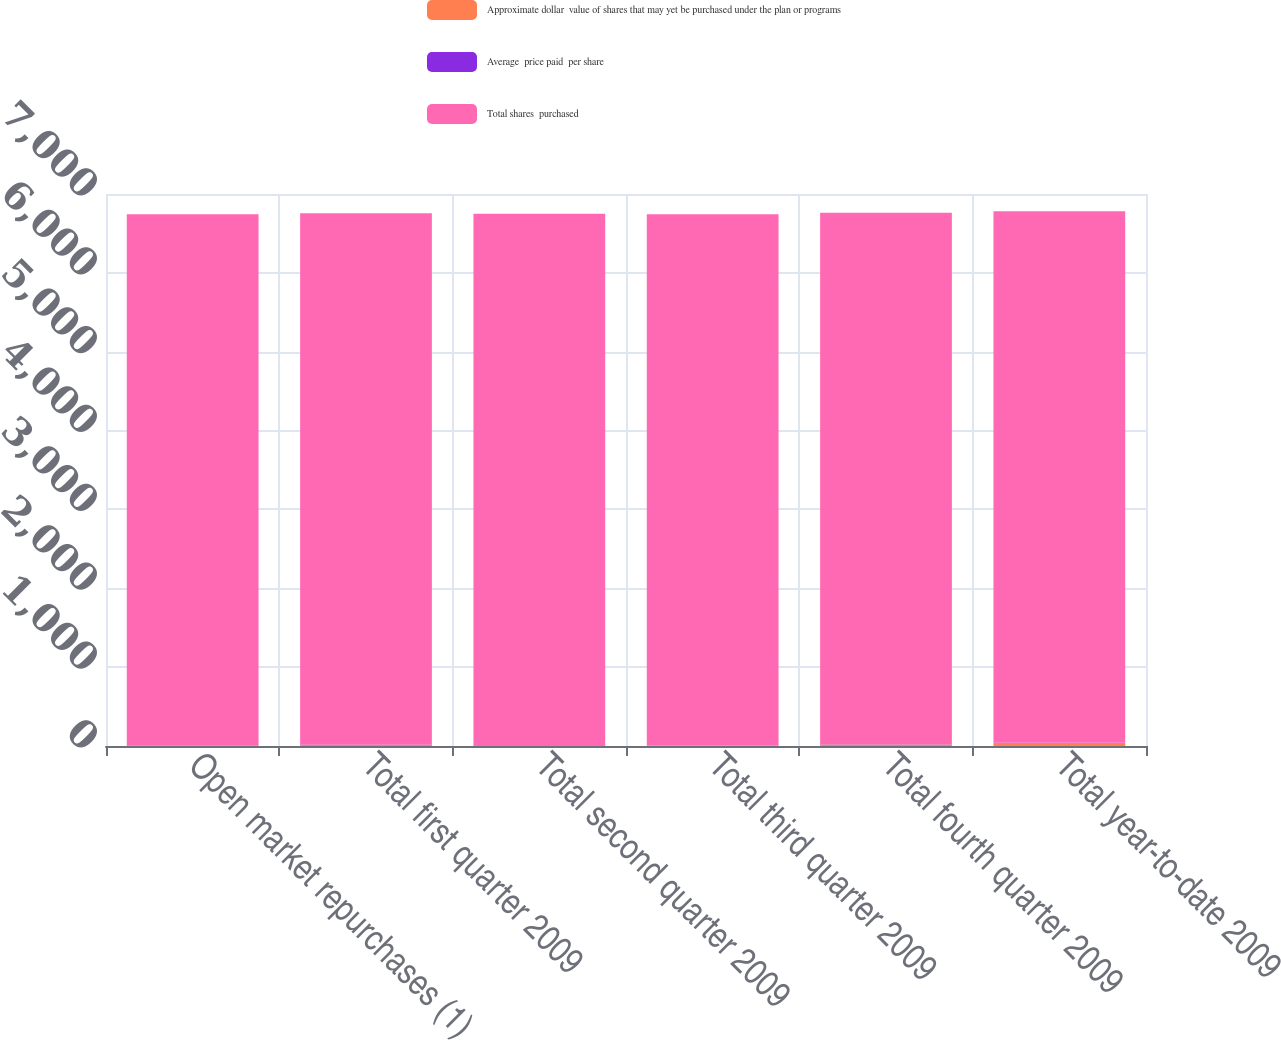<chart> <loc_0><loc_0><loc_500><loc_500><stacked_bar_chart><ecel><fcel>Open market repurchases (1)<fcel>Total first quarter 2009<fcel>Total second quarter 2009<fcel>Total third quarter 2009<fcel>Total fourth quarter 2009<fcel>Total year-to-date 2009<nl><fcel>Approximate dollar  value of shares that may yet be purchased under the plan or programs<fcel>0.2<fcel>10.9<fcel>4.6<fcel>1.8<fcel>19.8<fcel>37.1<nl><fcel>Average  price paid  per share<fcel>3.03<fcel>3.55<fcel>3.65<fcel>3.22<fcel>3.76<fcel>3.66<nl><fcel>Total shares  purchased<fcel>6741<fcel>6741<fcel>6740<fcel>6739<fcel>6739<fcel>6739<nl></chart> 